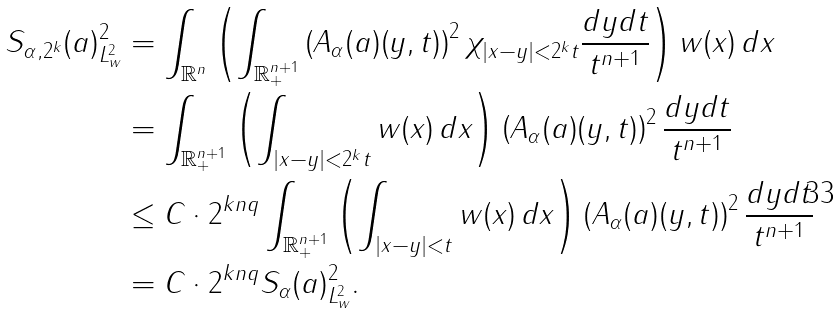<formula> <loc_0><loc_0><loc_500><loc_500>\| S _ { \alpha , 2 ^ { k } } ( a ) \| _ { L ^ { 2 } _ { w } } ^ { 2 } & = \int _ { \mathbb { R } ^ { n } } \left ( \int _ { { \mathbb { R } } ^ { n + 1 } _ { + } } \left ( A _ { \alpha } ( a ) ( y , t ) \right ) ^ { 2 } \chi _ { | x - y | < 2 ^ { k } t } \frac { d y d t } { t ^ { n + 1 } } \right ) w ( x ) \, d x \\ & = \int _ { { \mathbb { R } } ^ { n + 1 } _ { + } } \left ( \int _ { | x - y | < 2 ^ { k } t } w ( x ) \, d x \right ) \left ( A _ { \alpha } ( a ) ( y , t ) \right ) ^ { 2 } \frac { d y d t } { t ^ { n + 1 } } \\ & \leq C \cdot 2 ^ { k n q } \int _ { { \mathbb { R } } ^ { n + 1 } _ { + } } \left ( \int _ { | x - y | < t } w ( x ) \, d x \right ) \left ( A _ { \alpha } ( a ) ( y , t ) \right ) ^ { 2 } \frac { d y d t } { t ^ { n + 1 } } \\ & = C \cdot 2 ^ { k n q } \| S _ { \alpha } ( a ) \| _ { L ^ { 2 } _ { w } } ^ { 2 } .</formula> 